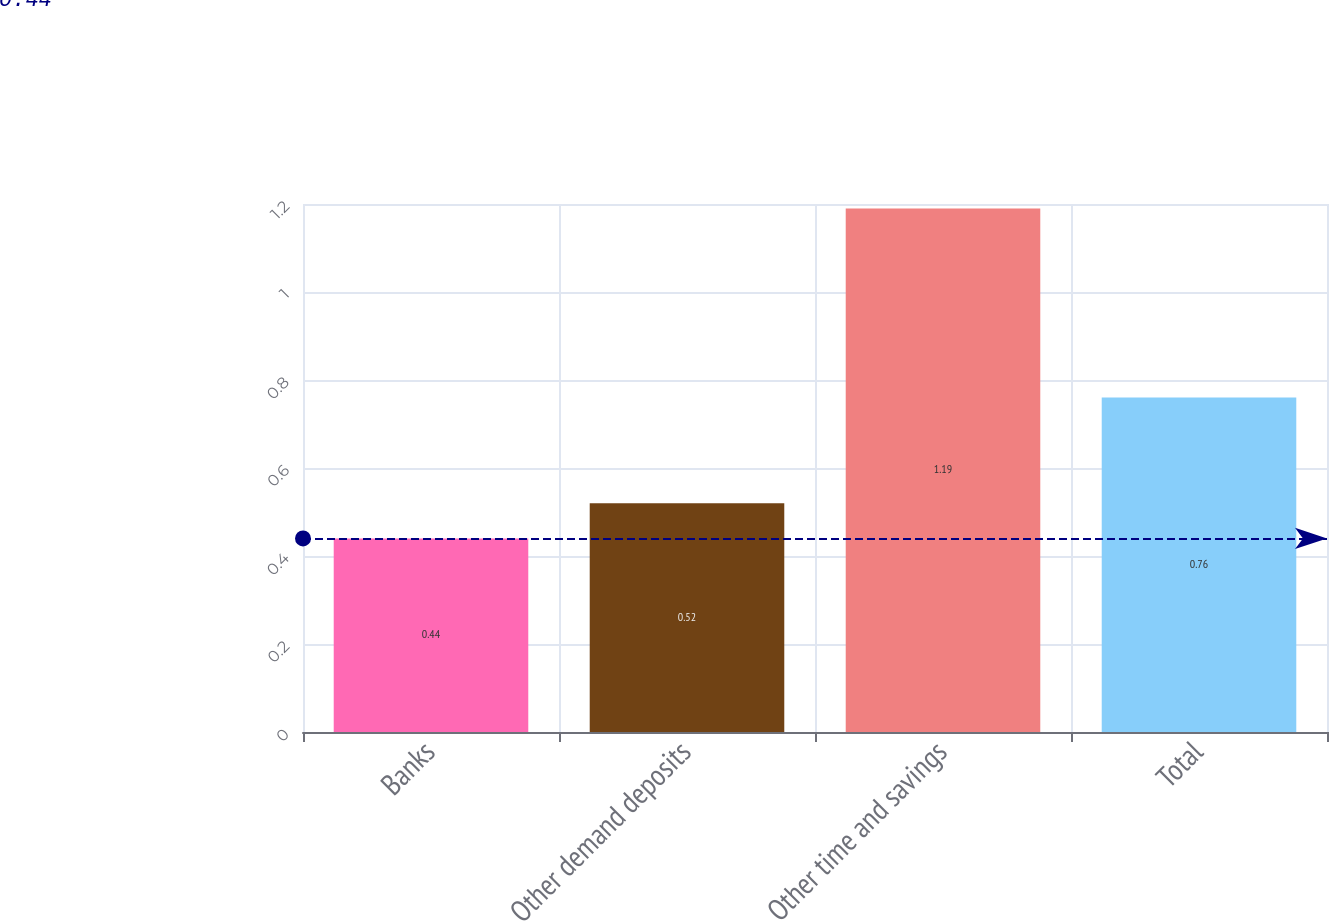Convert chart to OTSL. <chart><loc_0><loc_0><loc_500><loc_500><bar_chart><fcel>Banks<fcel>Other demand deposits<fcel>Other time and savings<fcel>Total<nl><fcel>0.44<fcel>0.52<fcel>1.19<fcel>0.76<nl></chart> 